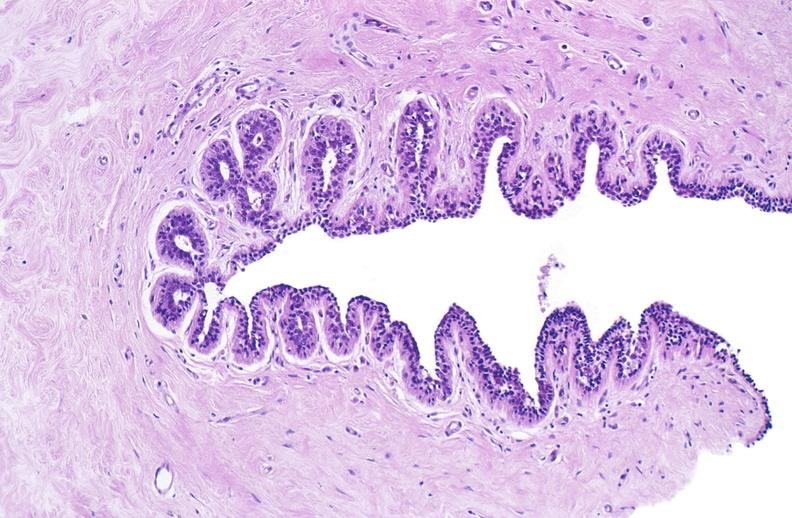where is this area in the body?
Answer the question using a single word or phrase. Breast 